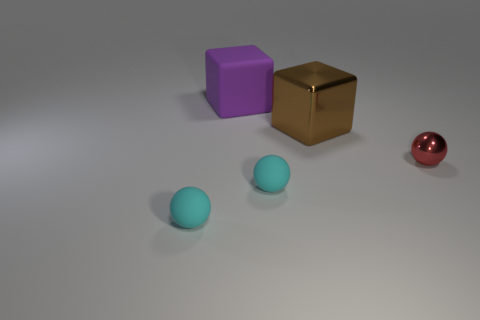Add 4 tiny red metal balls. How many objects exist? 9 Subtract all blocks. How many objects are left? 3 Subtract all large cyan metallic spheres. Subtract all rubber objects. How many objects are left? 2 Add 2 red things. How many red things are left? 3 Add 5 purple cubes. How many purple cubes exist? 6 Subtract 0 yellow blocks. How many objects are left? 5 